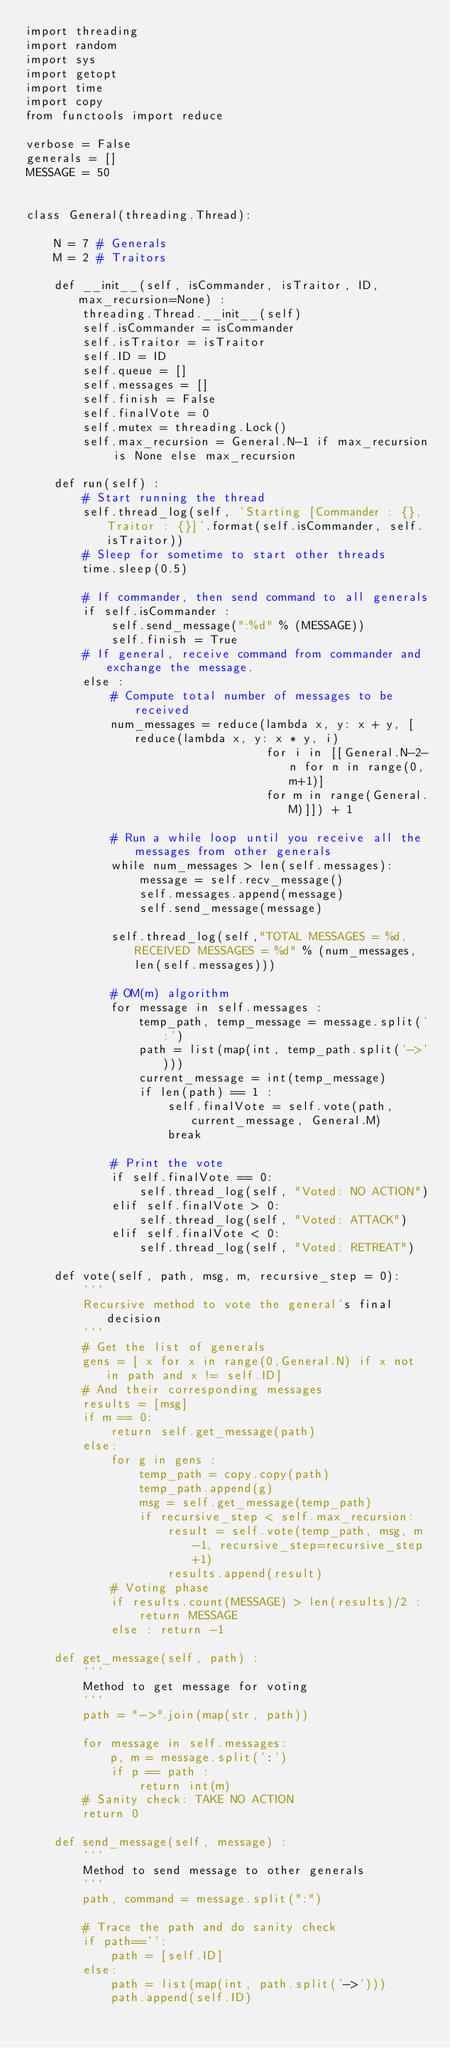<code> <loc_0><loc_0><loc_500><loc_500><_Python_>import threading
import random
import sys
import getopt
import time
import copy
from functools import reduce

verbose = False
generals = []
MESSAGE = 50


class General(threading.Thread):
    
    N = 7 # Generals
    M = 2 # Traitors
    
    def __init__(self, isCommander, isTraitor, ID, max_recursion=None) :
        threading.Thread.__init__(self)
        self.isCommander = isCommander
        self.isTraitor = isTraitor
        self.ID = ID
        self.queue = []
        self.messages = []
        self.finish = False
        self.finalVote = 0
        self.mutex = threading.Lock()
        self.max_recursion = General.N-1 if max_recursion is None else max_recursion
	   
    def run(self) :
        # Start running the thread
        self.thread_log(self, 'Starting [Commander : {}, Traitor : {}]'.format(self.isCommander, self.isTraitor))
        # Sleep for sometime to start other threads
        time.sleep(0.5)

        # If commander, then send command to all generals
        if self.isCommander :
            self.send_message(":%d" % (MESSAGE))
            self.finish = True
        # If general, receive command from commander and exchange the message.
        else :
            # Compute total number of messages to be received
            num_messages = reduce(lambda x, y: x + y, [reduce(lambda x, y: x * y, i)
                                  for i in [[General.N-2-n for n in range(0, m+1)]
                                  for m in range(General.M)]]) + 1
                            
            # Run a while loop until you receive all the messages from other generals
            while num_messages > len(self.messages):
                message = self.recv_message()
                self.messages.append(message)
                self.send_message(message)
            
            self.thread_log(self,"TOTAL MESSAGES = %d, RECEIVED MESSAGES = %d" % (num_messages, len(self.messages)))
            
            # OM(m) algorithm
            for message in self.messages :
                temp_path, temp_message = message.split(':')
                path = list(map(int, temp_path.split('->')))
                current_message = int(temp_message)
                if len(path) == 1 :
                    self.finalVote = self.vote(path, current_message, General.M)
                    break
            
            # Print the vote
            if self.finalVote == 0:
                self.thread_log(self, "Voted: NO ACTION")
            elif self.finalVote > 0:
                self.thread_log(self, "Voted: ATTACK")
            elif self.finalVote < 0:
                self.thread_log(self, "Voted: RETREAT")
			   
    def vote(self, path, msg, m, recursive_step = 0):
        '''
        Recursive method to vote the general's final decision
        '''
        # Get the list of generals
        gens = [ x for x in range(0,General.N) if x not in path and x != self.ID]
        # And their corresponding messages
        results = [msg]
        if m == 0:
            return self.get_message(path)
        else:
            for g in gens :
                temp_path = copy.copy(path)
                temp_path.append(g)
                msg = self.get_message(temp_path)
                if recursive_step < self.max_recursion:
                    result = self.vote(temp_path, msg, m-1, recursive_step=recursive_step+1)
                    results.append(result)
            # Voting phase
            if results.count(MESSAGE) > len(results)/2 : 
                return MESSAGE
            else : return -1		   
	   
    def get_message(self, path) :
        '''
        Method to get message for voting
        '''
        path = "->".join(map(str, path))

        for message in self.messages:
            p, m = message.split(':')
            if p == path :
                return int(m)
        # Sanity check: TAKE NO ACTION
        return 0
			   
    def send_message(self, message) :
        '''
        Method to send message to other generals
        '''
        path, command = message.split(":")
        
        # Trace the path and do sanity check
        if path=='':
            path = [self.ID]
        else:
            path = list(map(int, path.split('->')))
            path.append(self.ID)</code> 